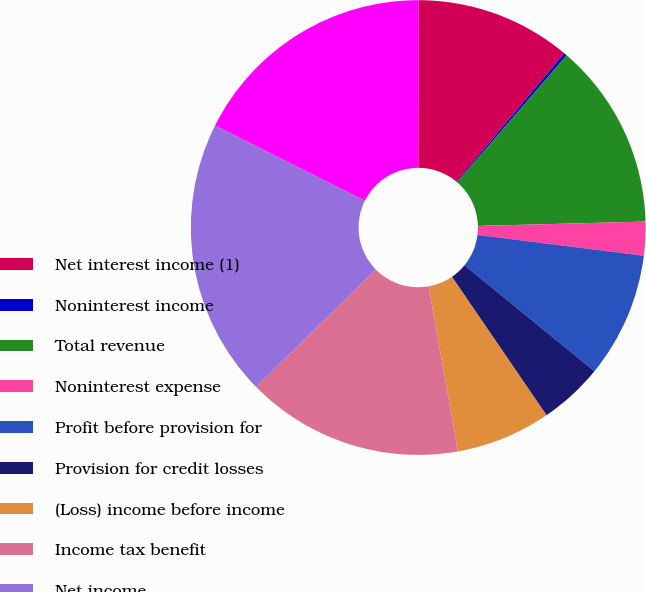Convert chart to OTSL. <chart><loc_0><loc_0><loc_500><loc_500><pie_chart><fcel>Net interest income (1)<fcel>Noninterest income<fcel>Total revenue<fcel>Noninterest expense<fcel>Profit before provision for<fcel>Provision for credit losses<fcel>(Loss) income before income<fcel>Income tax benefit<fcel>Net income<fcel>Loans and leases (period-end)<nl><fcel>11.09%<fcel>0.22%<fcel>13.26%<fcel>2.4%<fcel>8.91%<fcel>4.57%<fcel>6.74%<fcel>15.43%<fcel>19.78%<fcel>17.6%<nl></chart> 